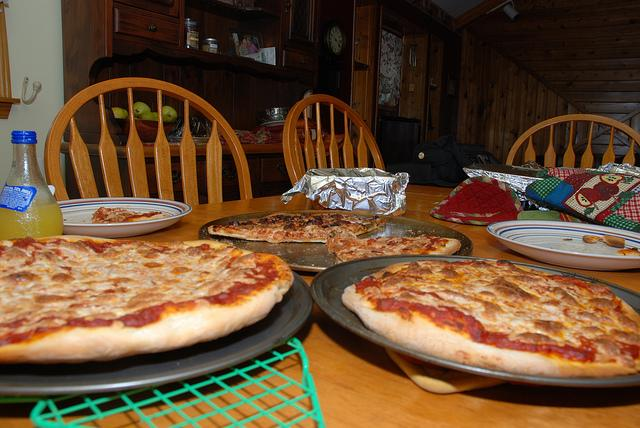The glass drink on the table has what as its primary flavor? Please explain your reasoning. citrus. The shape of the container suggests that it is a fruit and the color supports that it may be a citrus flavor. 